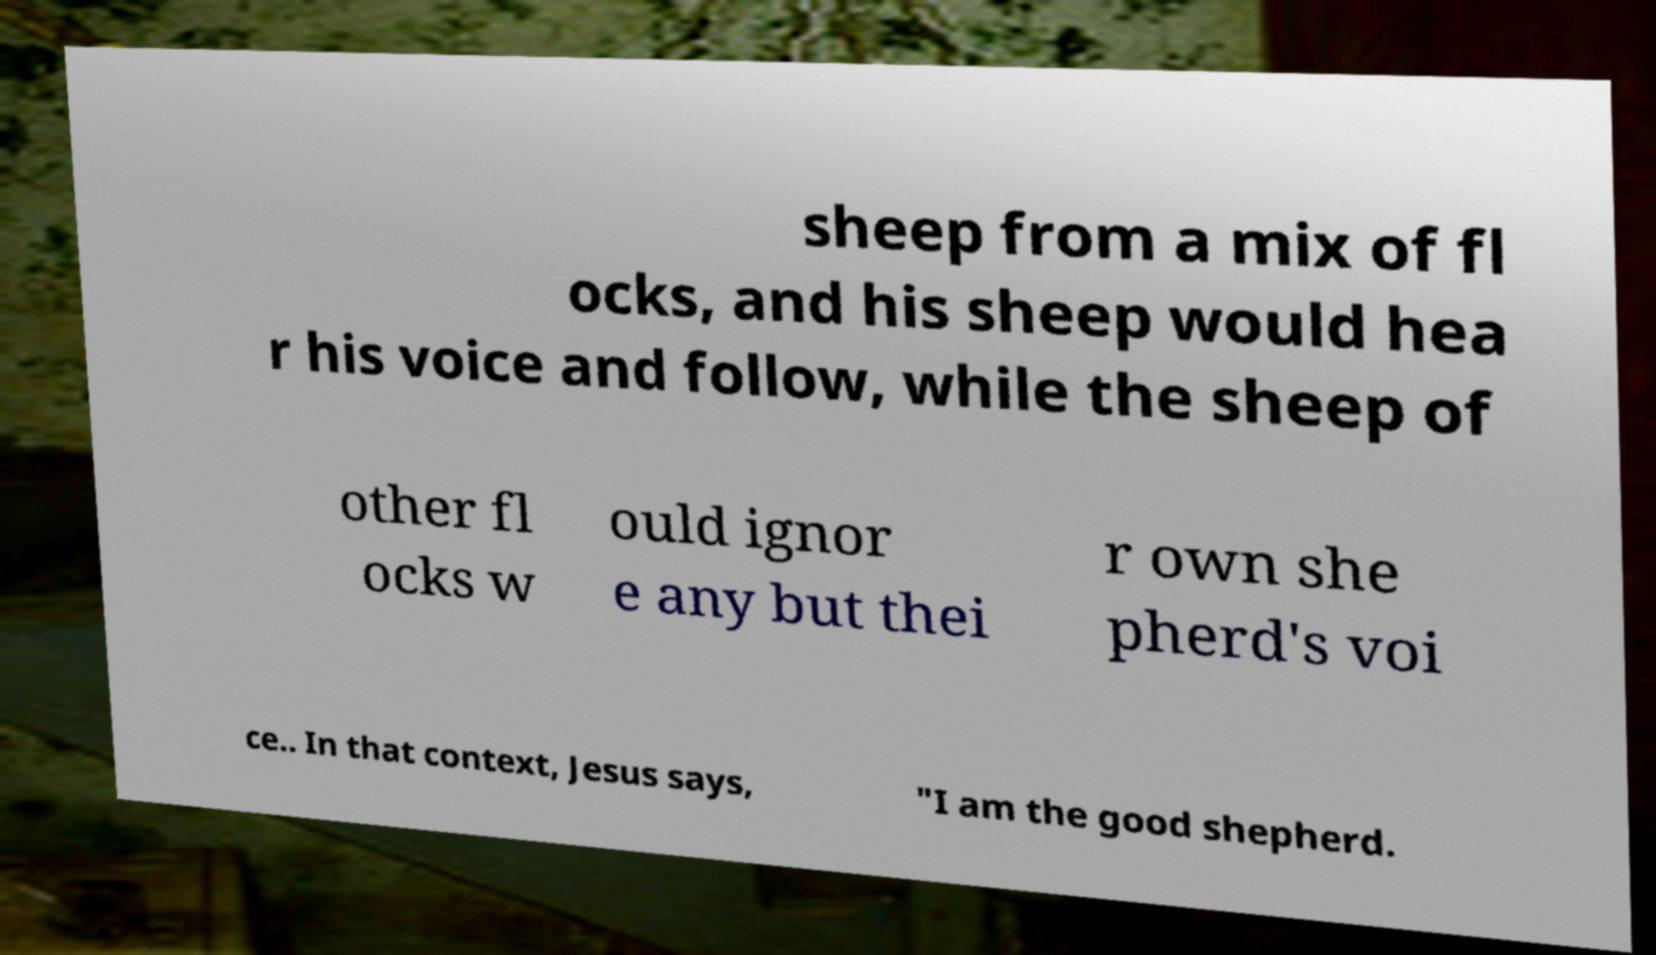Can you read and provide the text displayed in the image?This photo seems to have some interesting text. Can you extract and type it out for me? sheep from a mix of fl ocks, and his sheep would hea r his voice and follow, while the sheep of other fl ocks w ould ignor e any but thei r own she pherd's voi ce.. In that context, Jesus says, "I am the good shepherd. 